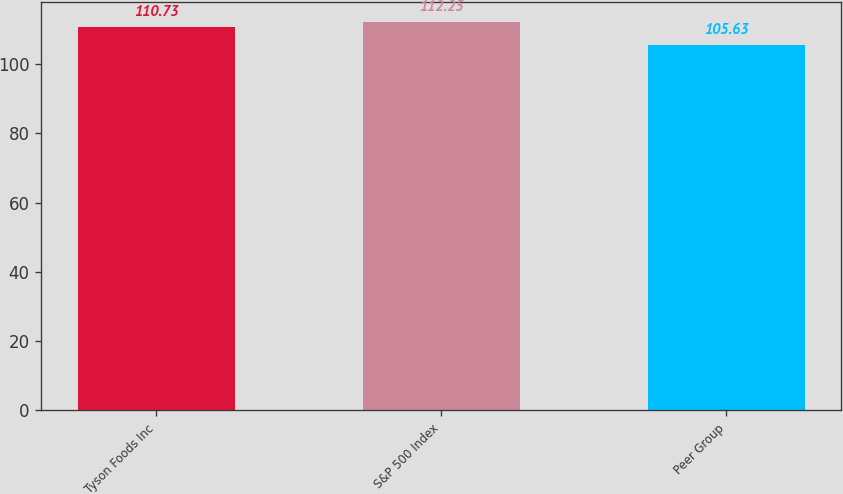<chart> <loc_0><loc_0><loc_500><loc_500><bar_chart><fcel>Tyson Foods Inc<fcel>S&P 500 Index<fcel>Peer Group<nl><fcel>110.73<fcel>112.25<fcel>105.63<nl></chart> 